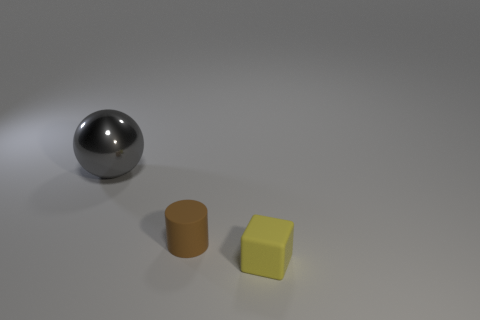Add 2 small matte things. How many objects exist? 5 Subtract all balls. How many objects are left? 2 Subtract all tiny yellow matte cubes. Subtract all blue rubber balls. How many objects are left? 2 Add 3 gray spheres. How many gray spheres are left? 4 Add 3 big purple matte cubes. How many big purple matte cubes exist? 3 Subtract 0 brown blocks. How many objects are left? 3 